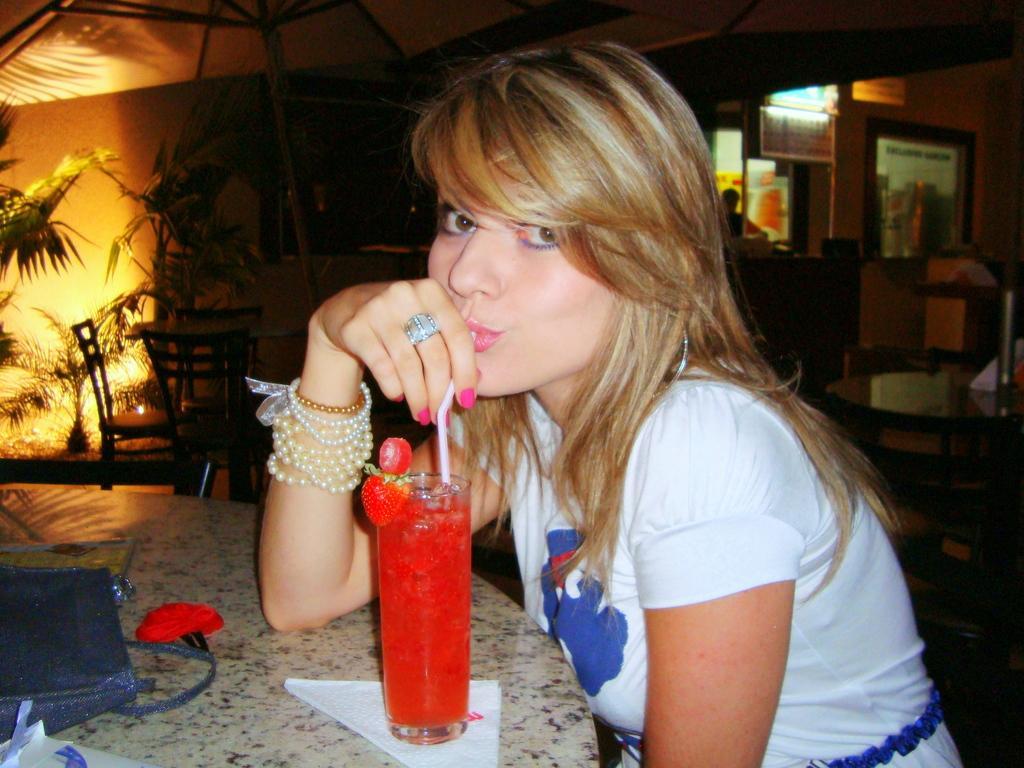Can you describe this image briefly? In this image in front there is a person drinking a juice. In front of her there is a table and on top of it there are clips, tissues, handbag. Behind her there are tables, chairs. On the left side of the image there are plants, lights. On the right side of the image there is a wall with the photo frame on it. There is a person standing in front of the table. 